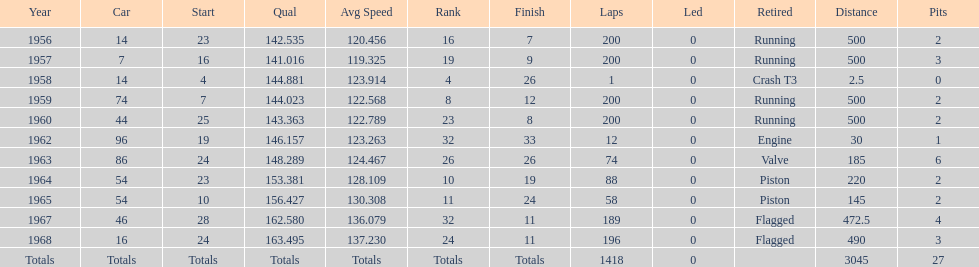What was its best starting position? 4. 